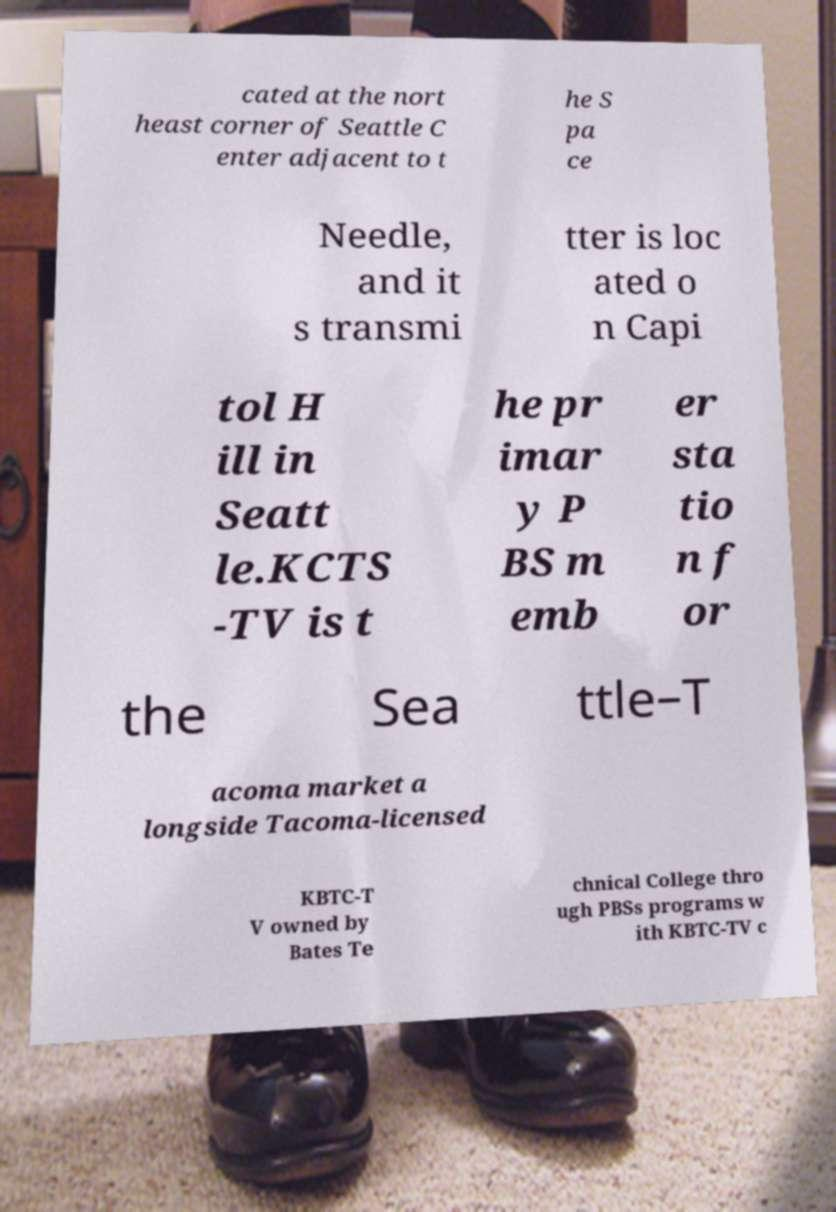I need the written content from this picture converted into text. Can you do that? cated at the nort heast corner of Seattle C enter adjacent to t he S pa ce Needle, and it s transmi tter is loc ated o n Capi tol H ill in Seatt le.KCTS -TV is t he pr imar y P BS m emb er sta tio n f or the Sea ttle–T acoma market a longside Tacoma-licensed KBTC-T V owned by Bates Te chnical College thro ugh PBSs programs w ith KBTC-TV c 